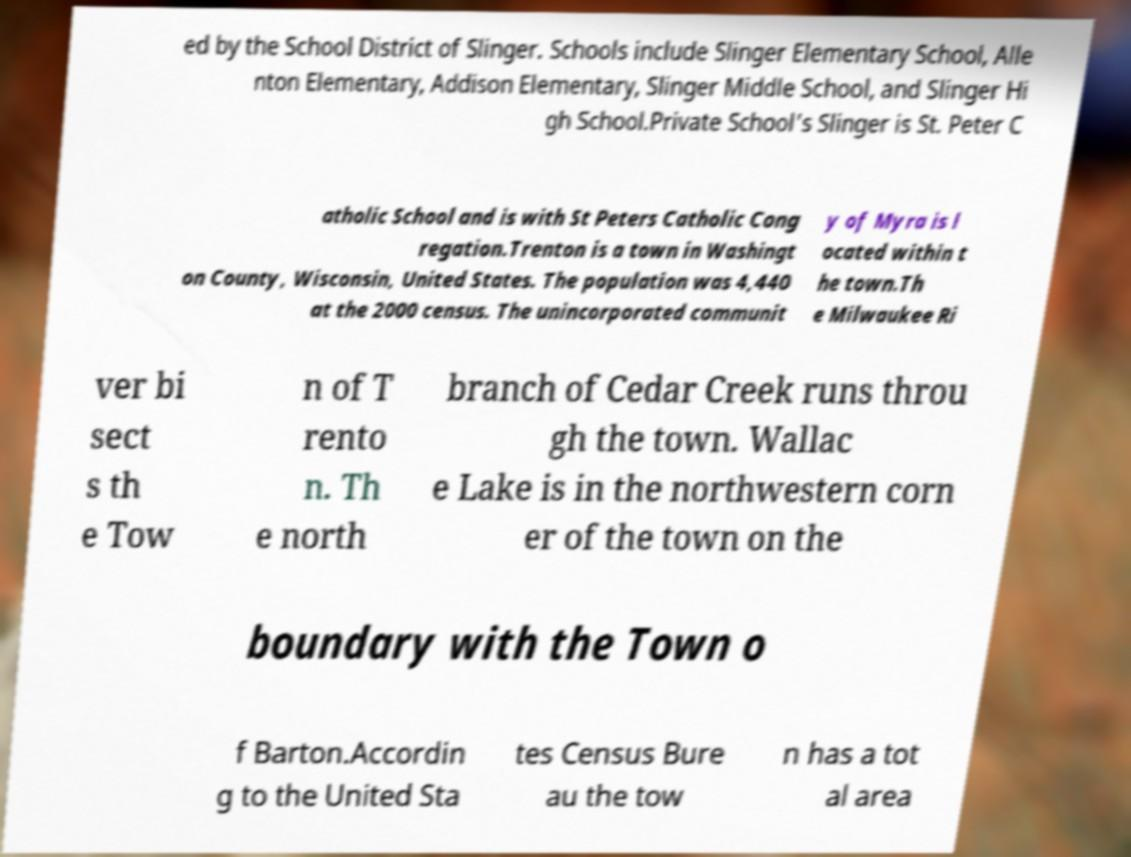Can you accurately transcribe the text from the provided image for me? ed by the School District of Slinger. Schools include Slinger Elementary School, Alle nton Elementary, Addison Elementary, Slinger Middle School, and Slinger Hi gh School.Private School's Slinger is St. Peter C atholic School and is with St Peters Catholic Cong regation.Trenton is a town in Washingt on County, Wisconsin, United States. The population was 4,440 at the 2000 census. The unincorporated communit y of Myra is l ocated within t he town.Th e Milwaukee Ri ver bi sect s th e Tow n of T rento n. Th e north branch of Cedar Creek runs throu gh the town. Wallac e Lake is in the northwestern corn er of the town on the boundary with the Town o f Barton.Accordin g to the United Sta tes Census Bure au the tow n has a tot al area 